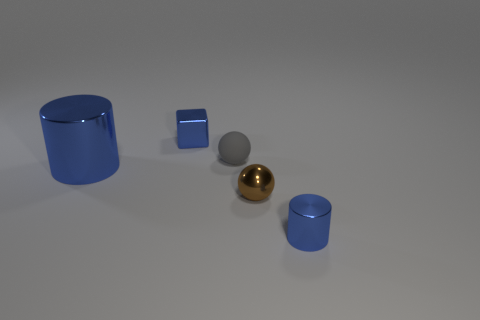Subtract 0 purple cylinders. How many objects are left? 5 Subtract all cubes. How many objects are left? 4 Subtract 2 spheres. How many spheres are left? 0 Subtract all green cylinders. Subtract all yellow spheres. How many cylinders are left? 2 Subtract all cyan cylinders. How many gray balls are left? 1 Subtract all small gray objects. Subtract all large yellow rubber spheres. How many objects are left? 4 Add 4 blue metallic things. How many blue metallic things are left? 7 Add 2 brown matte spheres. How many brown matte spheres exist? 2 Add 1 gray rubber things. How many objects exist? 6 Subtract all brown spheres. How many spheres are left? 1 